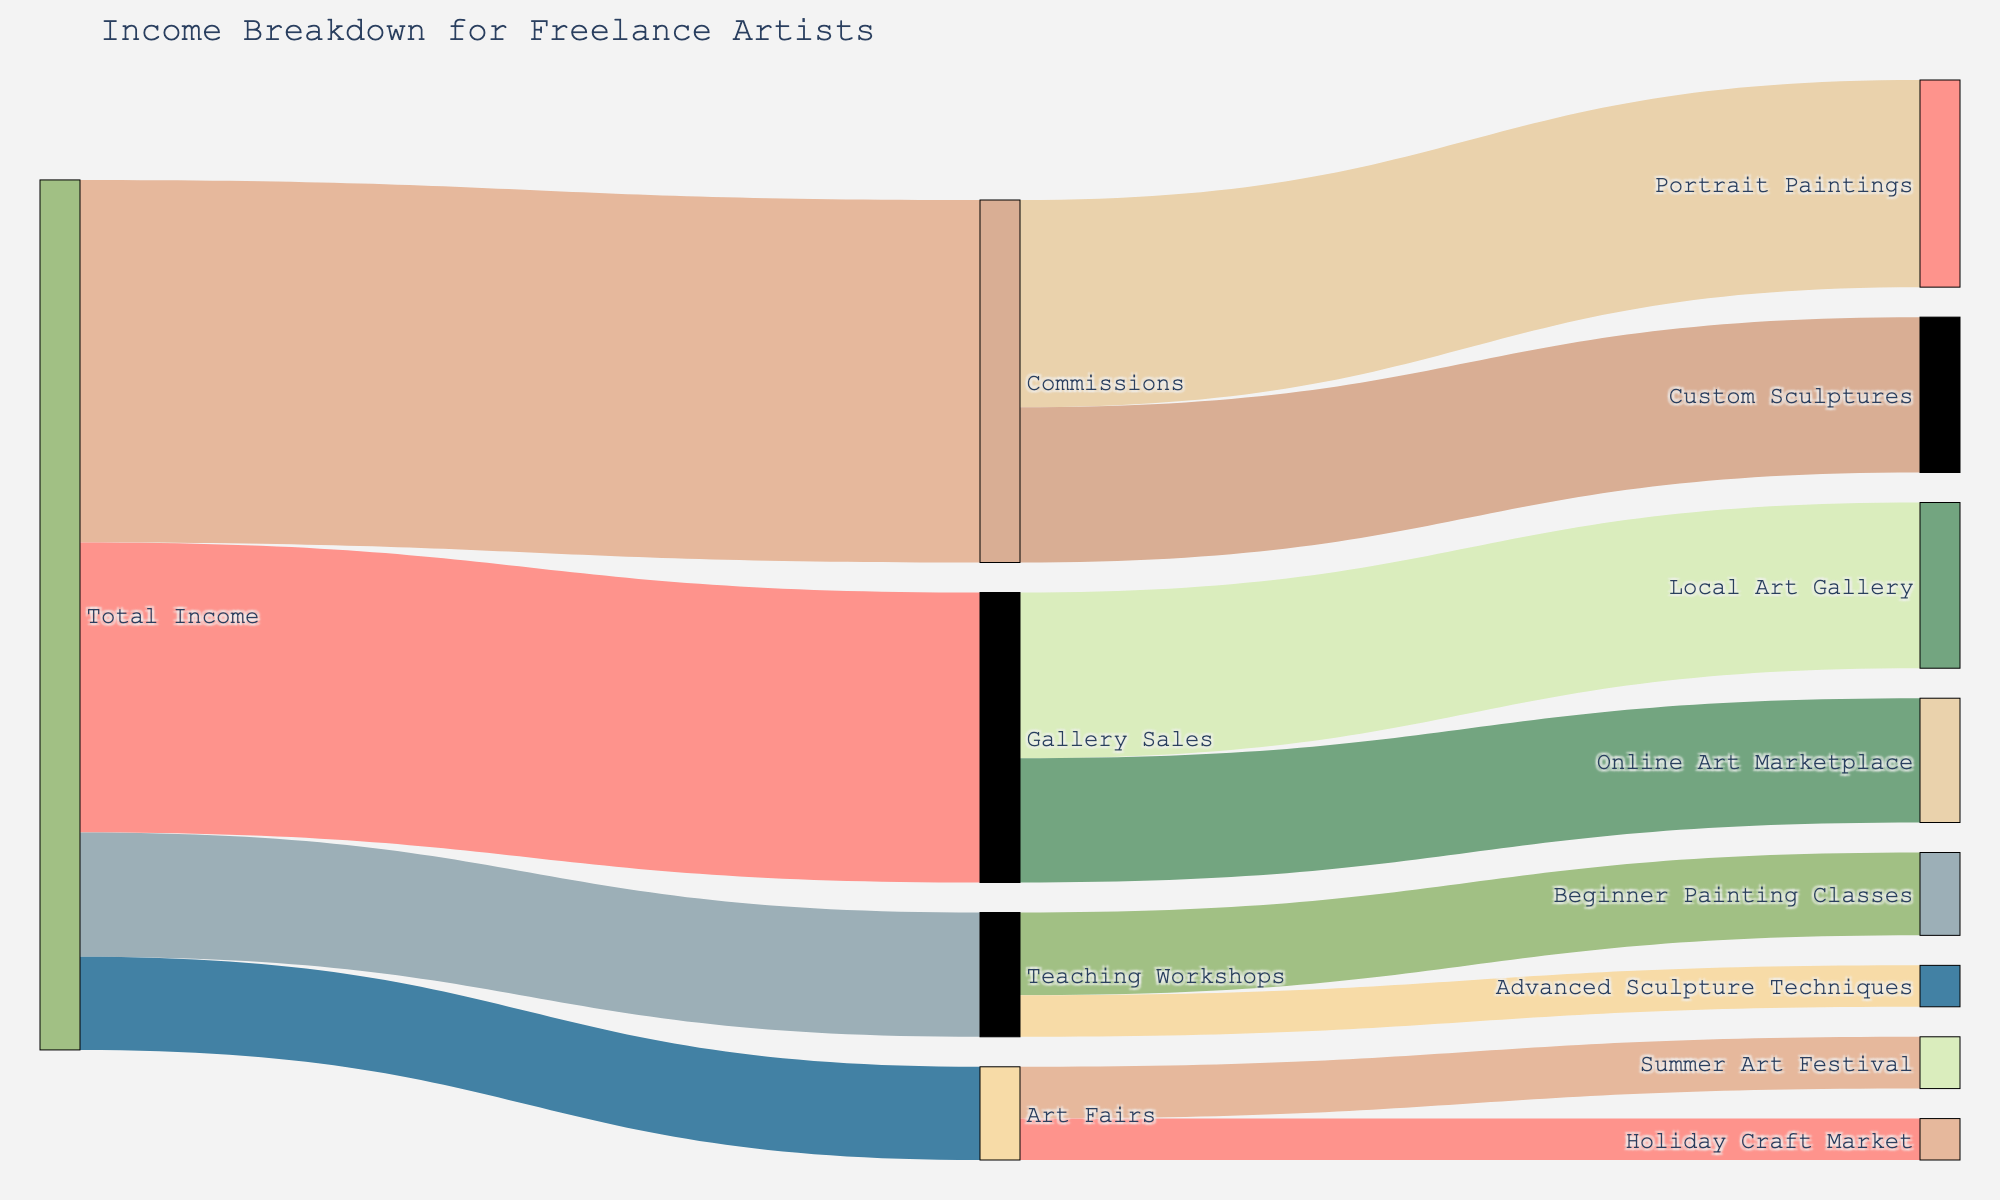What is the title of the diagram? The title of the diagram is located at the top and gives an overview of what the figure represents. It helps in understanding the subject matter of the visual.
Answer: Income Breakdown for Freelance Artists What are the main categories of income sources for the freelance artists shown in the diagram? To find the main categories, look at the nodes connected directly to the "Total Income" node. These categories are the first layer of branches stemming from the total income.
Answer: Commissions, Gallery Sales, Teaching Workshops, Art Fairs Which income source contributes the most to the total income? Compare the values connected to the "Total Income" node. The largest value indicates the largest contributor.
Answer: Commissions How much income is generated from Gallery Sales? Identify the value connected to the "Total Income" node that links to "Gallery Sales."
Answer: 2800 What percentage of the commission income comes from custom sculptures? First, find the value of custom sculptures, which is 1500. Then, find the total commissions income, which is 3500. Calculate the percentage: (1500/3500) * 100%.
Answer: Approximately 42.86% Which event at the Art Fairs contributes the least to income? Compare the values linked to "Art Fairs." The smaller value will indicate the lesser contributor.
Answer: Holiday Craft Market Is there more income generated from Teaching Workshops or Art Fairs? Sum the values connected to each source. Teaching Workshops has 1200 and Art Fairs has 900. Compare the two sums.
Answer: Teaching Workshops How much more income is generated from Beginner Painting Classes compared to Advanced Sculpture Techniques? Look at the values associated with each of the sub-categories under Teaching Workshops. Beginner Painting Classes is 800 and Advanced Sculpture Techniques is 400. Subtract the smaller value from the larger value.
Answer: 400 What is the combined income from Portrait Paintings and Local Art Gallery? Sum the values from these sub-categories: Portrait Paintings (2000) and Local Art Gallery (1600).
Answer: 3600 Which category under Gallery Sales is more lucrative? Between "Local Art Gallery" and "Online Art Marketplace," compare their values.
Answer: Local Art Gallery 